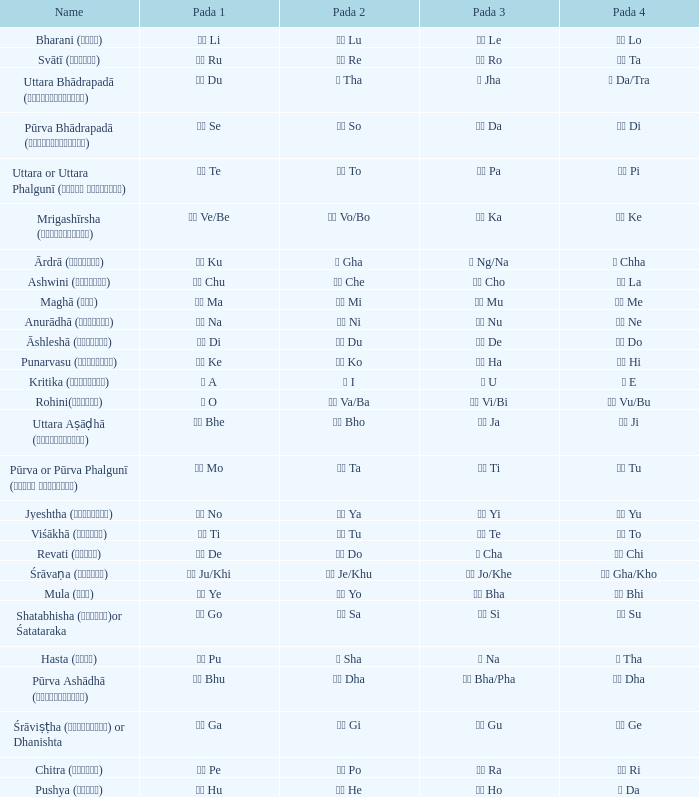What is the Name of ङ ng/na? Ārdrā (आर्द्रा). 